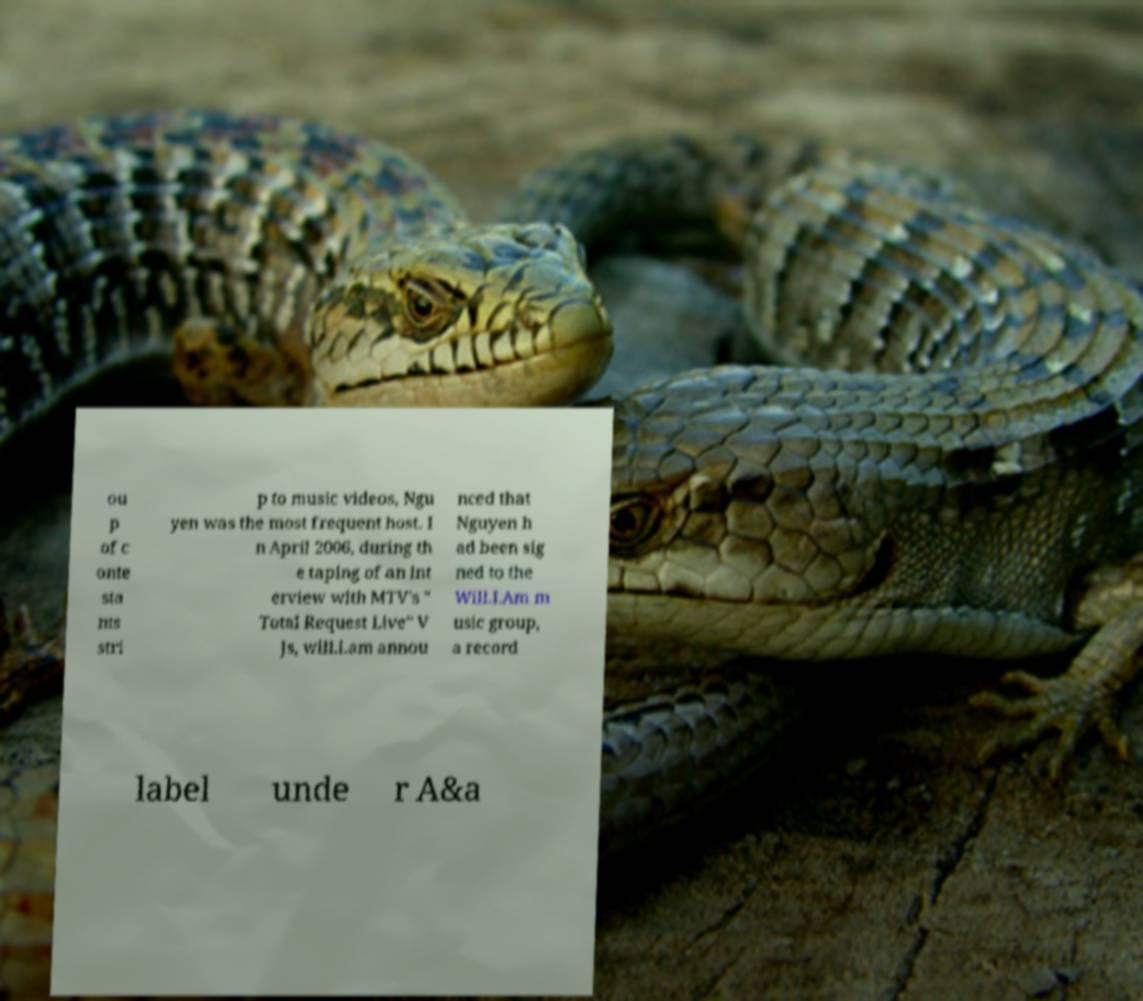There's text embedded in this image that I need extracted. Can you transcribe it verbatim? ou p of c onte sta nts stri p to music videos, Ngu yen was the most frequent host. I n April 2006, during th e taping of an int erview with MTV's " Total Request Live" V Js, will.i.am annou nced that Nguyen h ad been sig ned to the Will.I.Am m usic group, a record label unde r A&a 